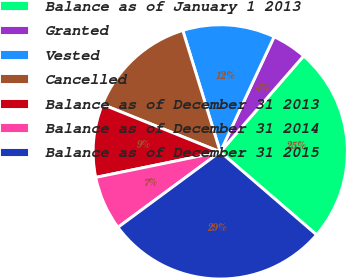Convert chart to OTSL. <chart><loc_0><loc_0><loc_500><loc_500><pie_chart><fcel>Balance as of January 1 2013<fcel>Granted<fcel>Vested<fcel>Cancelled<fcel>Balance as of December 31 2013<fcel>Balance as of December 31 2014<fcel>Balance as of December 31 2015<nl><fcel>24.93%<fcel>4.42%<fcel>11.73%<fcel>14.14%<fcel>9.31%<fcel>6.9%<fcel>28.57%<nl></chart> 